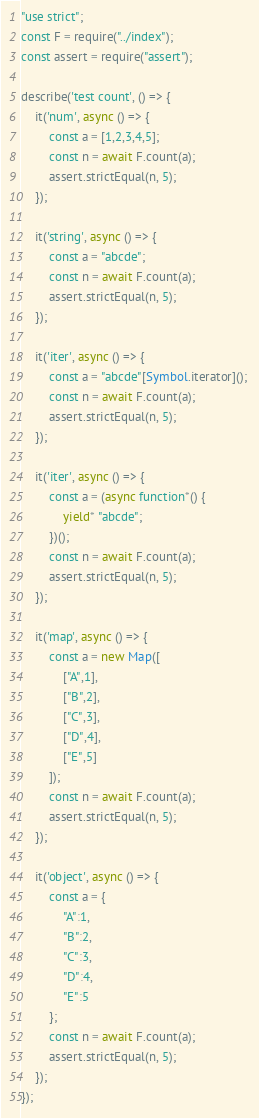Convert code to text. <code><loc_0><loc_0><loc_500><loc_500><_JavaScript_>"use strict";
const F = require("../index");
const assert = require("assert");

describe('test count', () => {
    it('num', async () => {
        const a = [1,2,3,4,5];
        const n = await F.count(a);
        assert.strictEqual(n, 5);
    });

    it('string', async () => {
        const a = "abcde"; 
        const n = await F.count(a);
        assert.strictEqual(n, 5);
    });

    it('iter', async () => {
        const a = "abcde"[Symbol.iterator](); 
        const n = await F.count(a);
        assert.strictEqual(n, 5);
    });

    it('iter', async () => {
        const a = (async function*() {
            yield* "abcde";
        })();
        const n = await F.count(a);
        assert.strictEqual(n, 5);
    });

    it('map', async () => {
        const a = new Map([
            ["A",1],
            ["B",2],
            ["C",3],
            ["D",4],
            ["E",5]
        ]);
        const n = await F.count(a);
        assert.strictEqual(n, 5);
    });

    it('object', async () => {
        const a = {
            "A":1,
            "B":2,
            "C":3,
            "D":4,
            "E":5
        }; 
        const n = await F.count(a);
        assert.strictEqual(n, 5);
    });
});</code> 